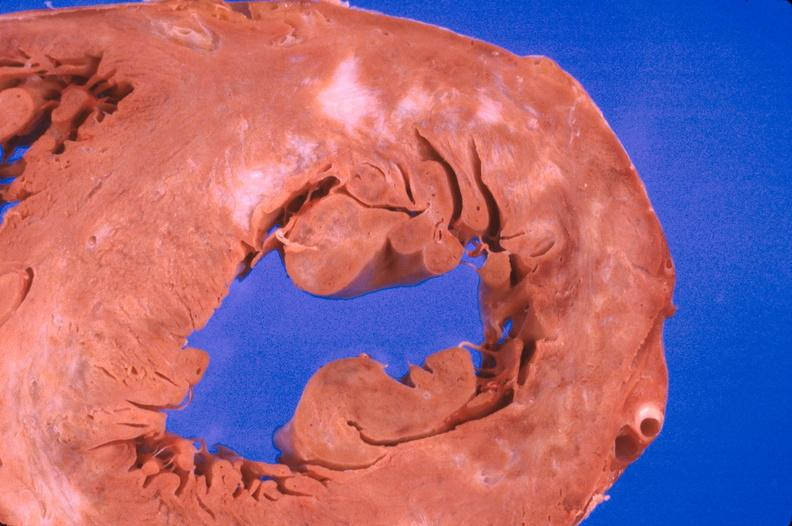what does this image show?
Answer the question using a single word or phrase. Heart 